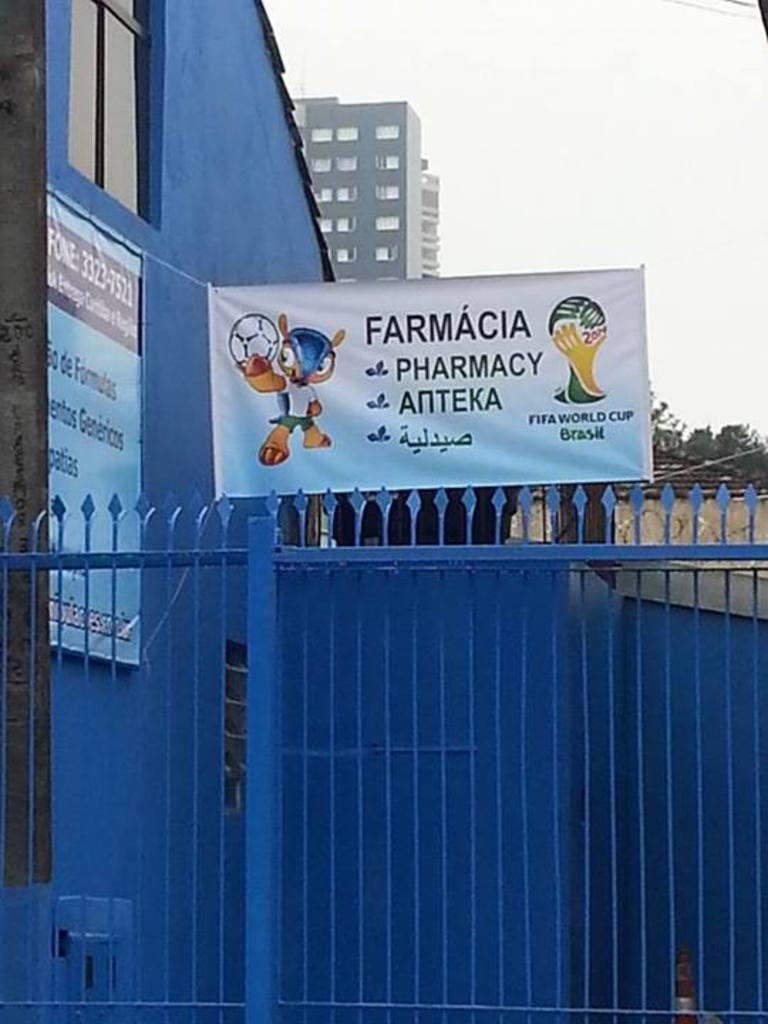Provide a one-sentence caption for the provided image. A banner advertising a pharmacy is hanging above a blue metal fence. 